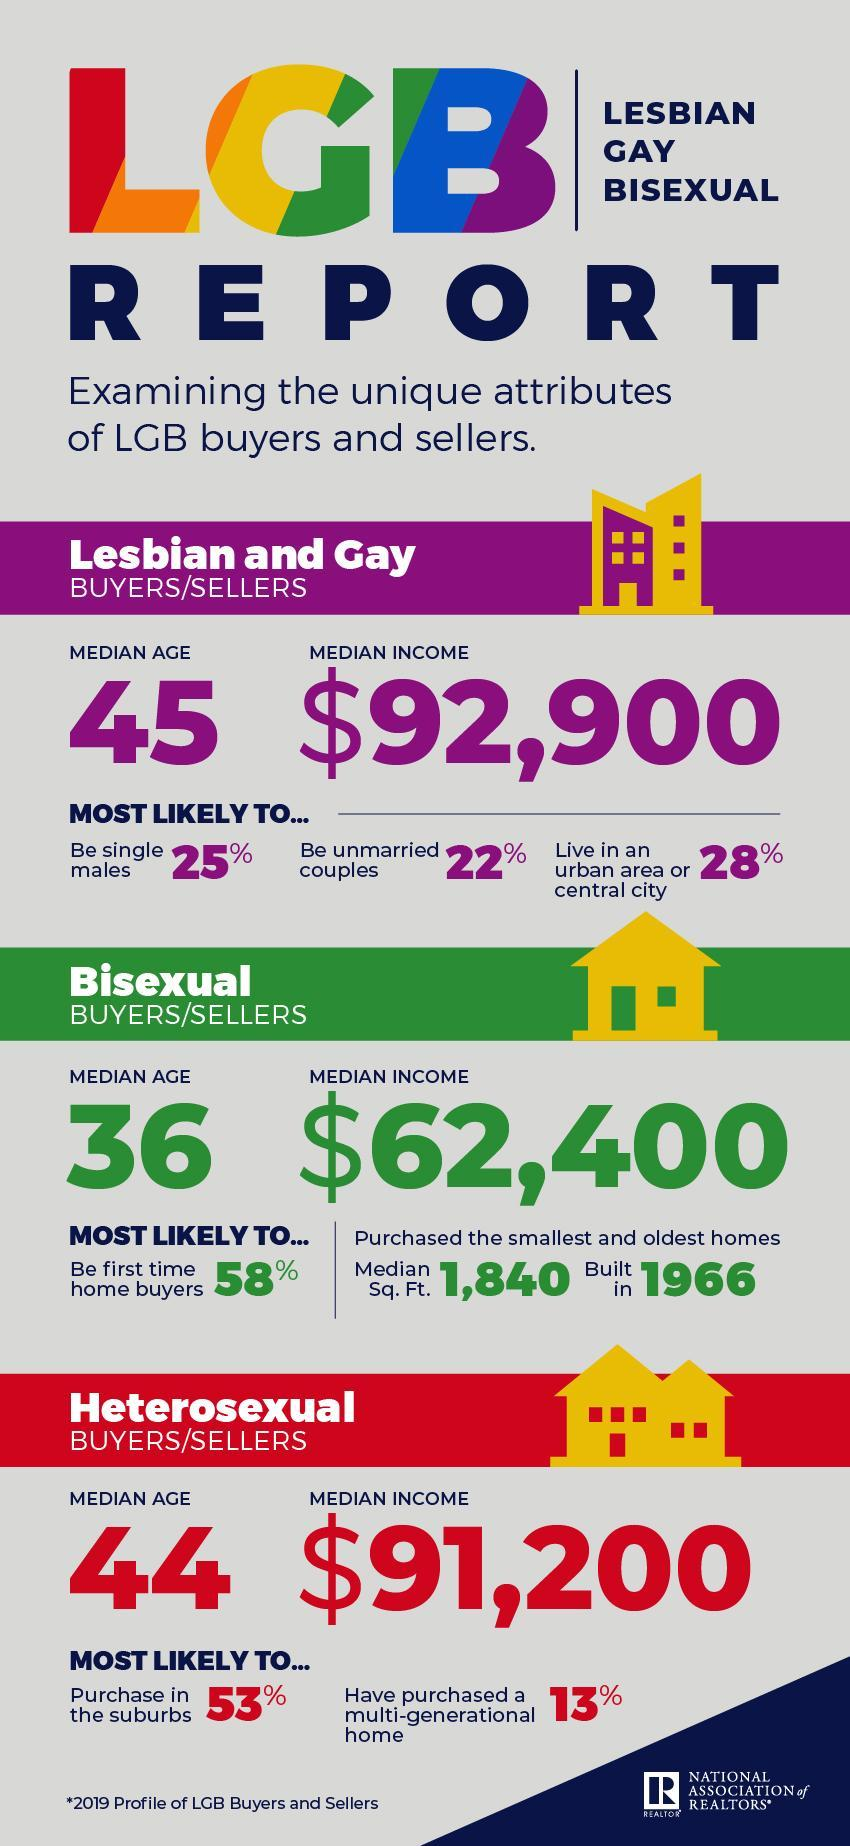Who among the three categories of buyers are bound to buy multi-generational homes, Lesbians/ Gays, Heterosexual, or Bisexual ?
Answer the question with a short phrase. Heterosexual Who among the three categories of buyers are bound to buy small or old homes, Heterosexual, Bisexual, or Lesbians/ Gays? Bisexual Which of the following categories of buyers/ sellers are bound to live in urban areas, Lesbian and Gay, Bisexual or Heterosexual ? Lesbian and Gay What is the median age gap between Lesbian and gay buyers or sellers and bisexual buyers or sellers ? 9 What is the total median income in all the categories of buyers and sellers? 246,500 